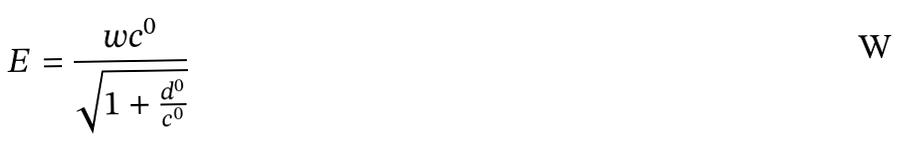<formula> <loc_0><loc_0><loc_500><loc_500>E = \frac { w c ^ { 0 } } { \sqrt { 1 + \frac { d ^ { 0 } } { c ^ { 0 } } } }</formula> 